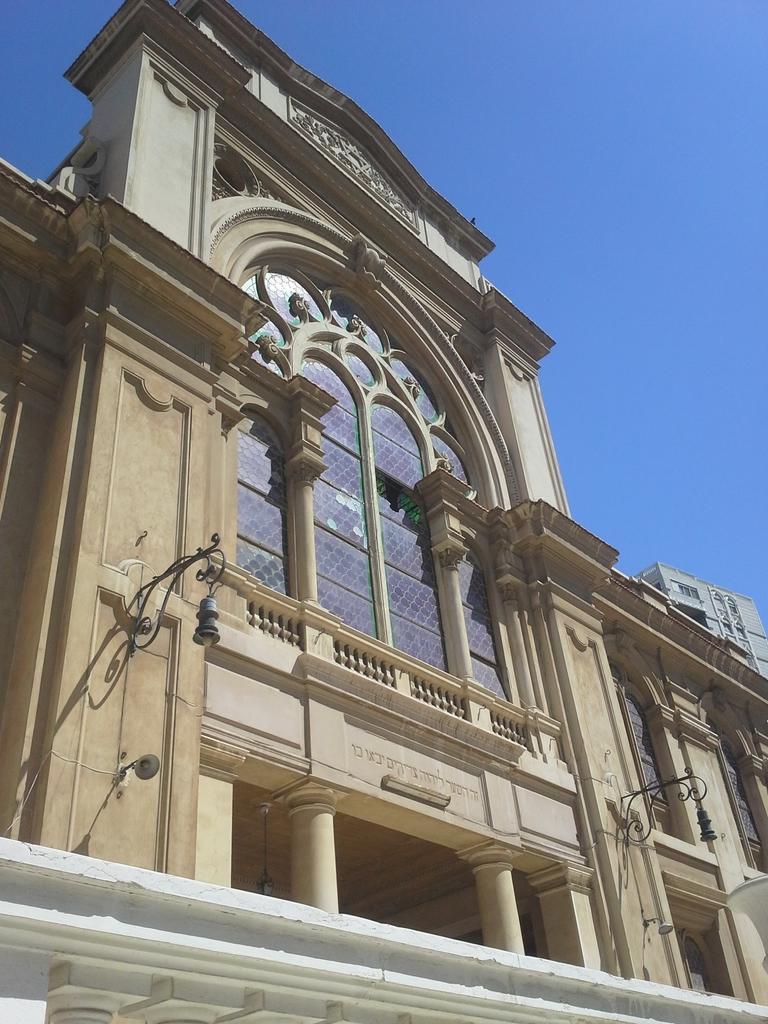Please provide a concise description of this image. In this picture we can see a building. On the right there is a light. On the top there is a sky. 